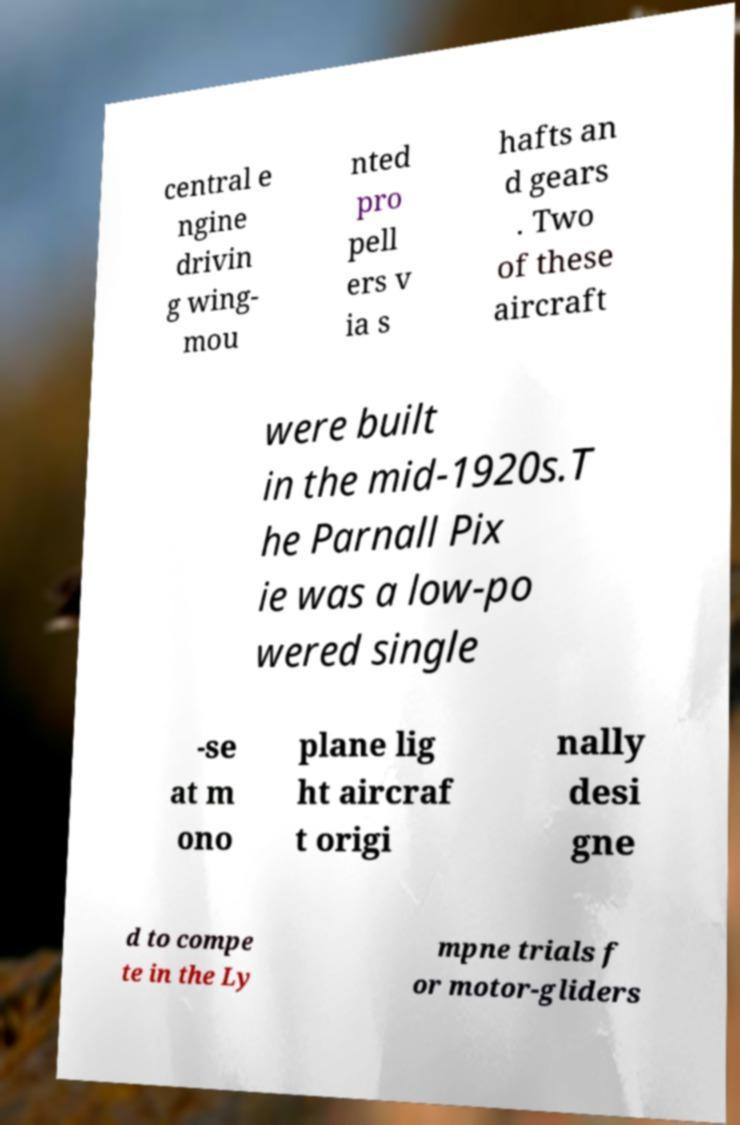Can you read and provide the text displayed in the image?This photo seems to have some interesting text. Can you extract and type it out for me? central e ngine drivin g wing- mou nted pro pell ers v ia s hafts an d gears . Two of these aircraft were built in the mid-1920s.T he Parnall Pix ie was a low-po wered single -se at m ono plane lig ht aircraf t origi nally desi gne d to compe te in the Ly mpne trials f or motor-gliders 